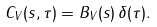<formula> <loc_0><loc_0><loc_500><loc_500>C _ { V } ( { s } , \tau ) = B _ { V } ( { s } ) \, \delta ( \tau ) .</formula> 